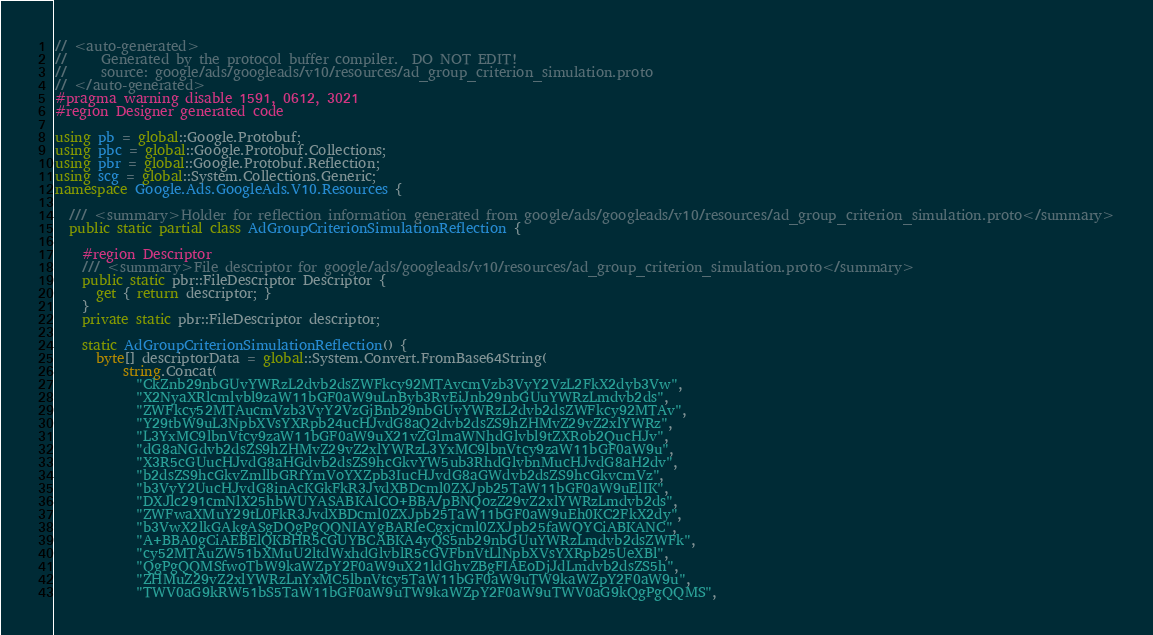<code> <loc_0><loc_0><loc_500><loc_500><_C#_>// <auto-generated>
//     Generated by the protocol buffer compiler.  DO NOT EDIT!
//     source: google/ads/googleads/v10/resources/ad_group_criterion_simulation.proto
// </auto-generated>
#pragma warning disable 1591, 0612, 3021
#region Designer generated code

using pb = global::Google.Protobuf;
using pbc = global::Google.Protobuf.Collections;
using pbr = global::Google.Protobuf.Reflection;
using scg = global::System.Collections.Generic;
namespace Google.Ads.GoogleAds.V10.Resources {

  /// <summary>Holder for reflection information generated from google/ads/googleads/v10/resources/ad_group_criterion_simulation.proto</summary>
  public static partial class AdGroupCriterionSimulationReflection {

    #region Descriptor
    /// <summary>File descriptor for google/ads/googleads/v10/resources/ad_group_criterion_simulation.proto</summary>
    public static pbr::FileDescriptor Descriptor {
      get { return descriptor; }
    }
    private static pbr::FileDescriptor descriptor;

    static AdGroupCriterionSimulationReflection() {
      byte[] descriptorData = global::System.Convert.FromBase64String(
          string.Concat(
            "CkZnb29nbGUvYWRzL2dvb2dsZWFkcy92MTAvcmVzb3VyY2VzL2FkX2dyb3Vw",
            "X2NyaXRlcmlvbl9zaW11bGF0aW9uLnByb3RvEiJnb29nbGUuYWRzLmdvb2ds",
            "ZWFkcy52MTAucmVzb3VyY2VzGjBnb29nbGUvYWRzL2dvb2dsZWFkcy92MTAv",
            "Y29tbW9uL3NpbXVsYXRpb24ucHJvdG8aQ2dvb2dsZS9hZHMvZ29vZ2xlYWRz",
            "L3YxMC9lbnVtcy9zaW11bGF0aW9uX21vZGlmaWNhdGlvbl9tZXRob2QucHJv",
            "dG8aNGdvb2dsZS9hZHMvZ29vZ2xlYWRzL3YxMC9lbnVtcy9zaW11bGF0aW9u",
            "X3R5cGUucHJvdG8aHGdvb2dsZS9hcGkvYW5ub3RhdGlvbnMucHJvdG8aH2dv",
            "b2dsZS9hcGkvZmllbGRfYmVoYXZpb3IucHJvdG8aGWdvb2dsZS9hcGkvcmVz",
            "b3VyY2UucHJvdG8inAcKGkFkR3JvdXBDcml0ZXJpb25TaW11bGF0aW9uElIK",
            "DXJlc291cmNlX25hbWUYASABKAlCO+BBA/pBNQozZ29vZ2xlYWRzLmdvb2ds",
            "ZWFwaXMuY29tL0FkR3JvdXBDcml0ZXJpb25TaW11bGF0aW9uEh0KC2FkX2dy",
            "b3VwX2lkGAkgASgDQgPgQQNIAYgBARIeCgxjcml0ZXJpb25faWQYCiABKANC",
            "A+BBA0gCiAEBElQKBHR5cGUYBCABKA4yQS5nb29nbGUuYWRzLmdvb2dsZWFk",
            "cy52MTAuZW51bXMuU2ltdWxhdGlvblR5cGVFbnVtLlNpbXVsYXRpb25UeXBl",
            "QgPgQQMSfwoTbW9kaWZpY2F0aW9uX21ldGhvZBgFIAEoDjJdLmdvb2dsZS5h",
            "ZHMuZ29vZ2xlYWRzLnYxMC5lbnVtcy5TaW11bGF0aW9uTW9kaWZpY2F0aW9u",
            "TWV0aG9kRW51bS5TaW11bGF0aW9uTW9kaWZpY2F0aW9uTWV0aG9kQgPgQQMS",</code> 